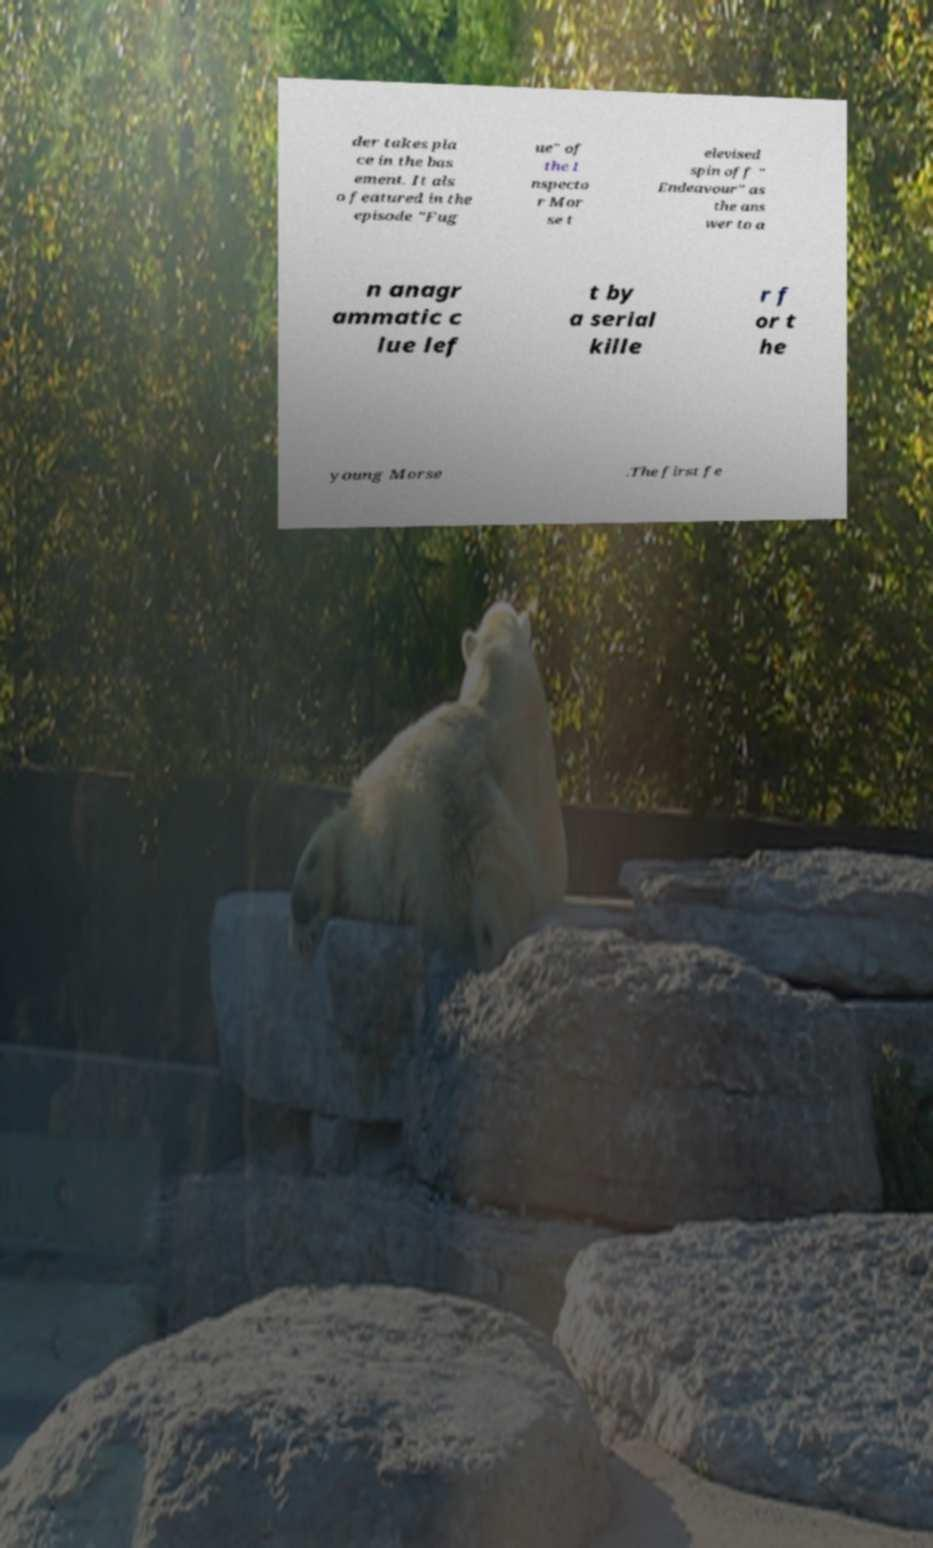For documentation purposes, I need the text within this image transcribed. Could you provide that? der takes pla ce in the bas ement. It als o featured in the episode "Fug ue" of the I nspecto r Mor se t elevised spin off " Endeavour" as the ans wer to a n anagr ammatic c lue lef t by a serial kille r f or t he young Morse .The first fe 